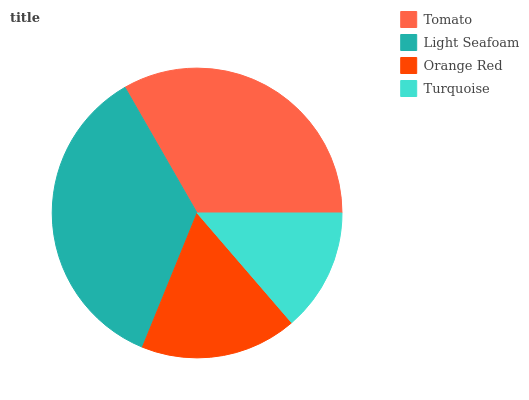Is Turquoise the minimum?
Answer yes or no. Yes. Is Light Seafoam the maximum?
Answer yes or no. Yes. Is Orange Red the minimum?
Answer yes or no. No. Is Orange Red the maximum?
Answer yes or no. No. Is Light Seafoam greater than Orange Red?
Answer yes or no. Yes. Is Orange Red less than Light Seafoam?
Answer yes or no. Yes. Is Orange Red greater than Light Seafoam?
Answer yes or no. No. Is Light Seafoam less than Orange Red?
Answer yes or no. No. Is Tomato the high median?
Answer yes or no. Yes. Is Orange Red the low median?
Answer yes or no. Yes. Is Orange Red the high median?
Answer yes or no. No. Is Turquoise the low median?
Answer yes or no. No. 